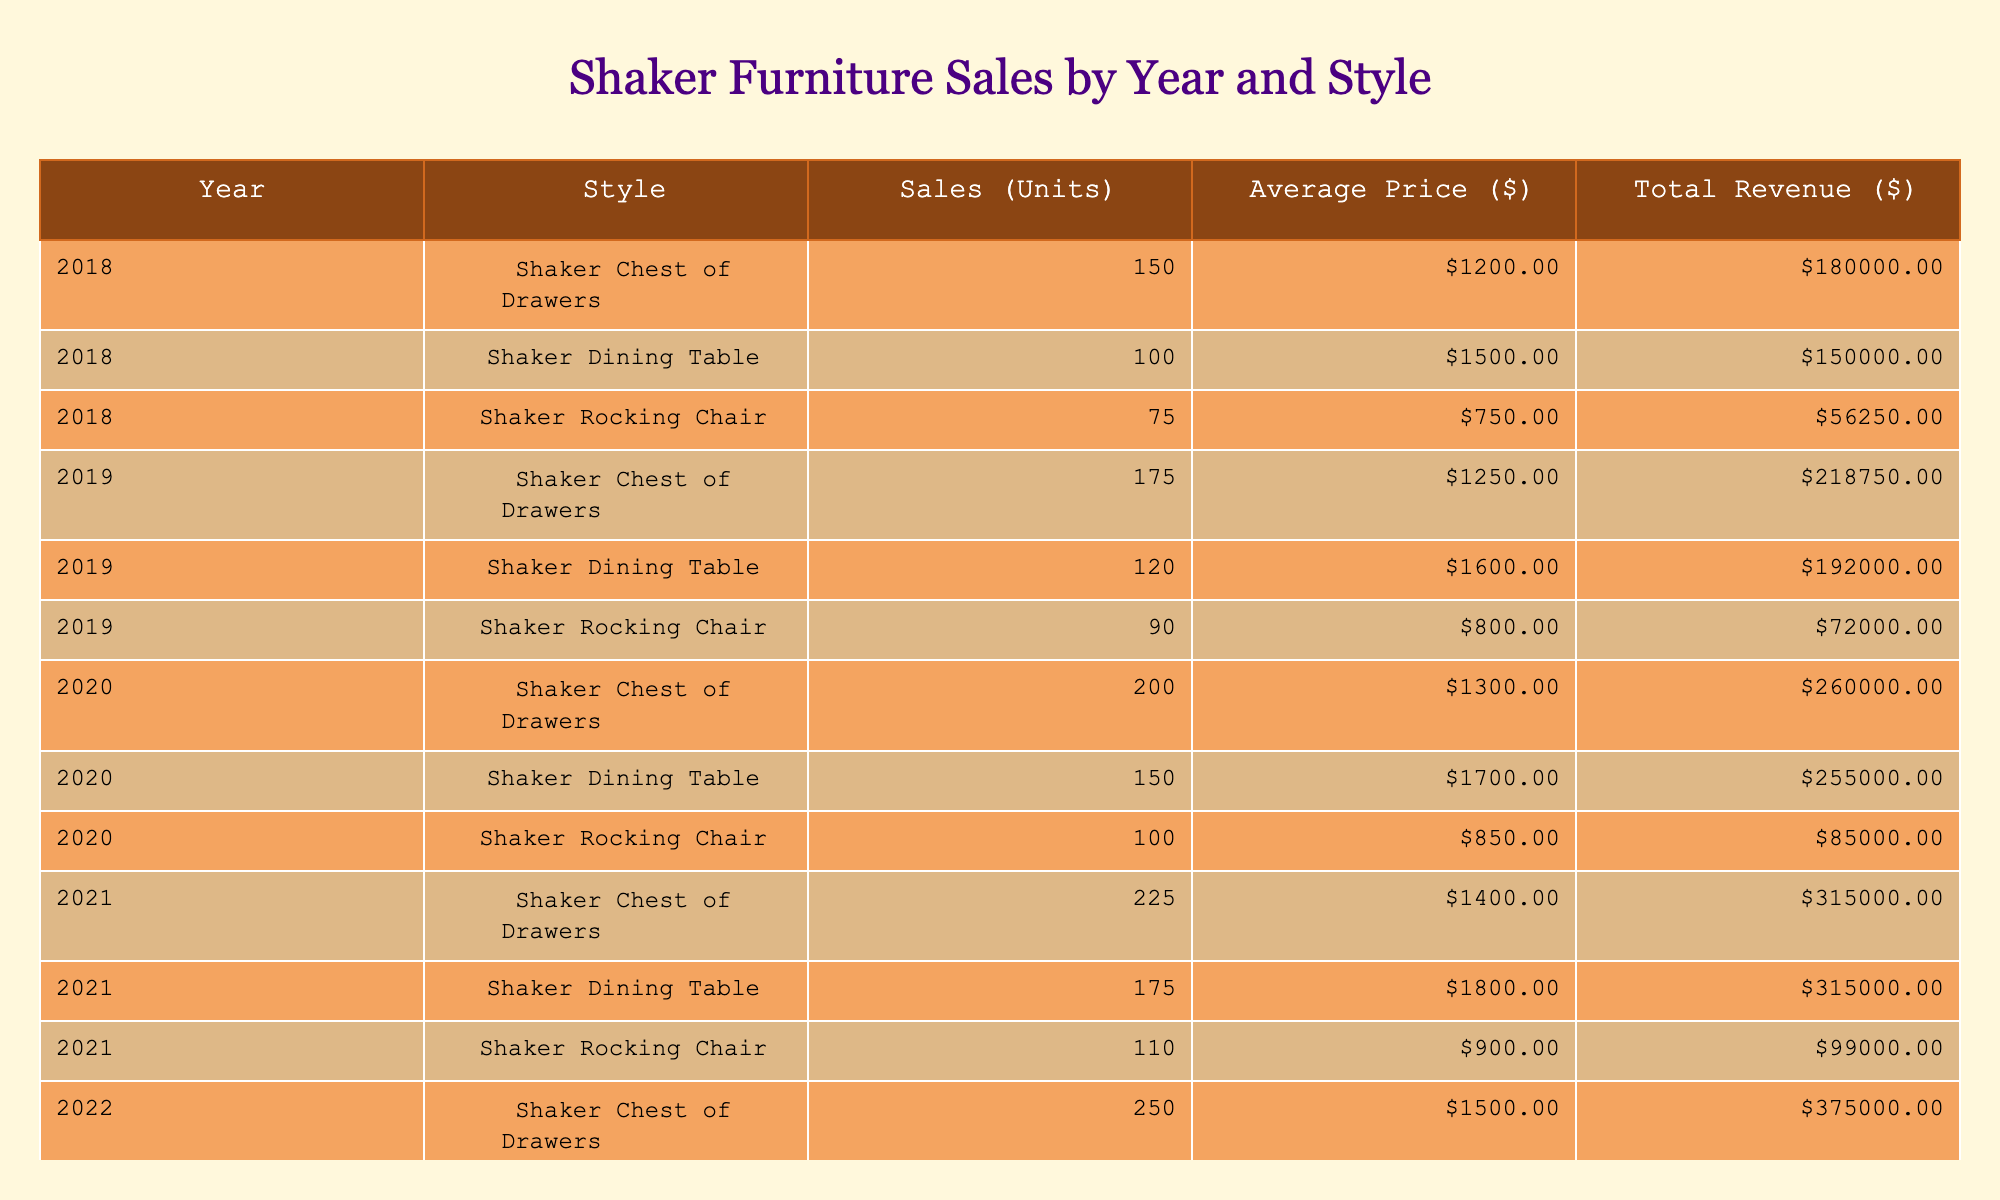What was the total revenue for Shaker Dining Tables in 2020? To find the total revenue for Shaker Dining Tables in 2020, we look at the table for that year and style. The total revenue listed is $255,000.
Answer: $255,000 Which year saw the highest sales volume for Shaker Chest of Drawers? Reviewing the table, we see the highest sales volume for Shaker Chest of Drawers was in 2023, with 275 units sold.
Answer: 2023 What is the average price of Shaker Rocking Chairs sold in 2021? The average price of Shaker Rocking Chairs in 2021, according to the table, is $900.
Answer: $900 Did the sales of Shaker Dining Tables increase every year? Examining the sales figures for Shaker Dining Tables across the years, we see 100 (2018), 120 (2019), 150 (2020), 175 (2021), 190 (2022), 210 (2023). Since the sales increased each year, the answer is yes.
Answer: Yes How much more revenue did Shaker Chest of Drawers generate in 2022 compared to 2018? The total revenue for Shaker Chest of Drawers in 2022 is $375,000 and in 2018 is $180,000. The difference is $375,000 - $180,000 = $195,000.
Answer: $195,000 What was the total number of Shaker Rocking Chairs sold from 2018 to 2022? Adding up the sales for Shaker Rocking Chairs: 75 (2018) + 90 (2019) + 100 (2020) + 110 (2021) + 120 (2022) gives us a total of 495 units sold.
Answer: 495 Which style had the highest sales in 2023, and what was the total? In 2023, Shaker Chest of Drawers had the highest sales with 275 units sold for $440,000 in total revenue.
Answer: Shaker Chest of Drawers, $440,000 What is the percentage increase in total revenue from 2019 to 2020 for Shaker Rocking Chairs? The total revenue for Shaker Rocking Chairs was $72,000 in 2019 and $85,000 in 2020. The increase is $85,000 - $72,000 = $13,000. The percentage increase is ($13,000 / $72,000) * 100 ≈ 18.06%.
Answer: Approximately 18.06% Which year had the lowest average price for Shaker Dining Tables? The average price for Shaker Dining Tables in each year is as follows: 2018 - $1500, 2019 - $1600, 2020 - $1700, 2021 - $1800, 2022 - $1900, 2023 - $2000. The lowest average price is $1500 in 2018.
Answer: 2018 How many total units of all Shaker furniture styles were sold in 2021? The total units sold in 2021 for each style are 225 (Chest of Drawers) + 175 (Dining Table) + 110 (Rocking Chair) = 510 units.
Answer: 510 